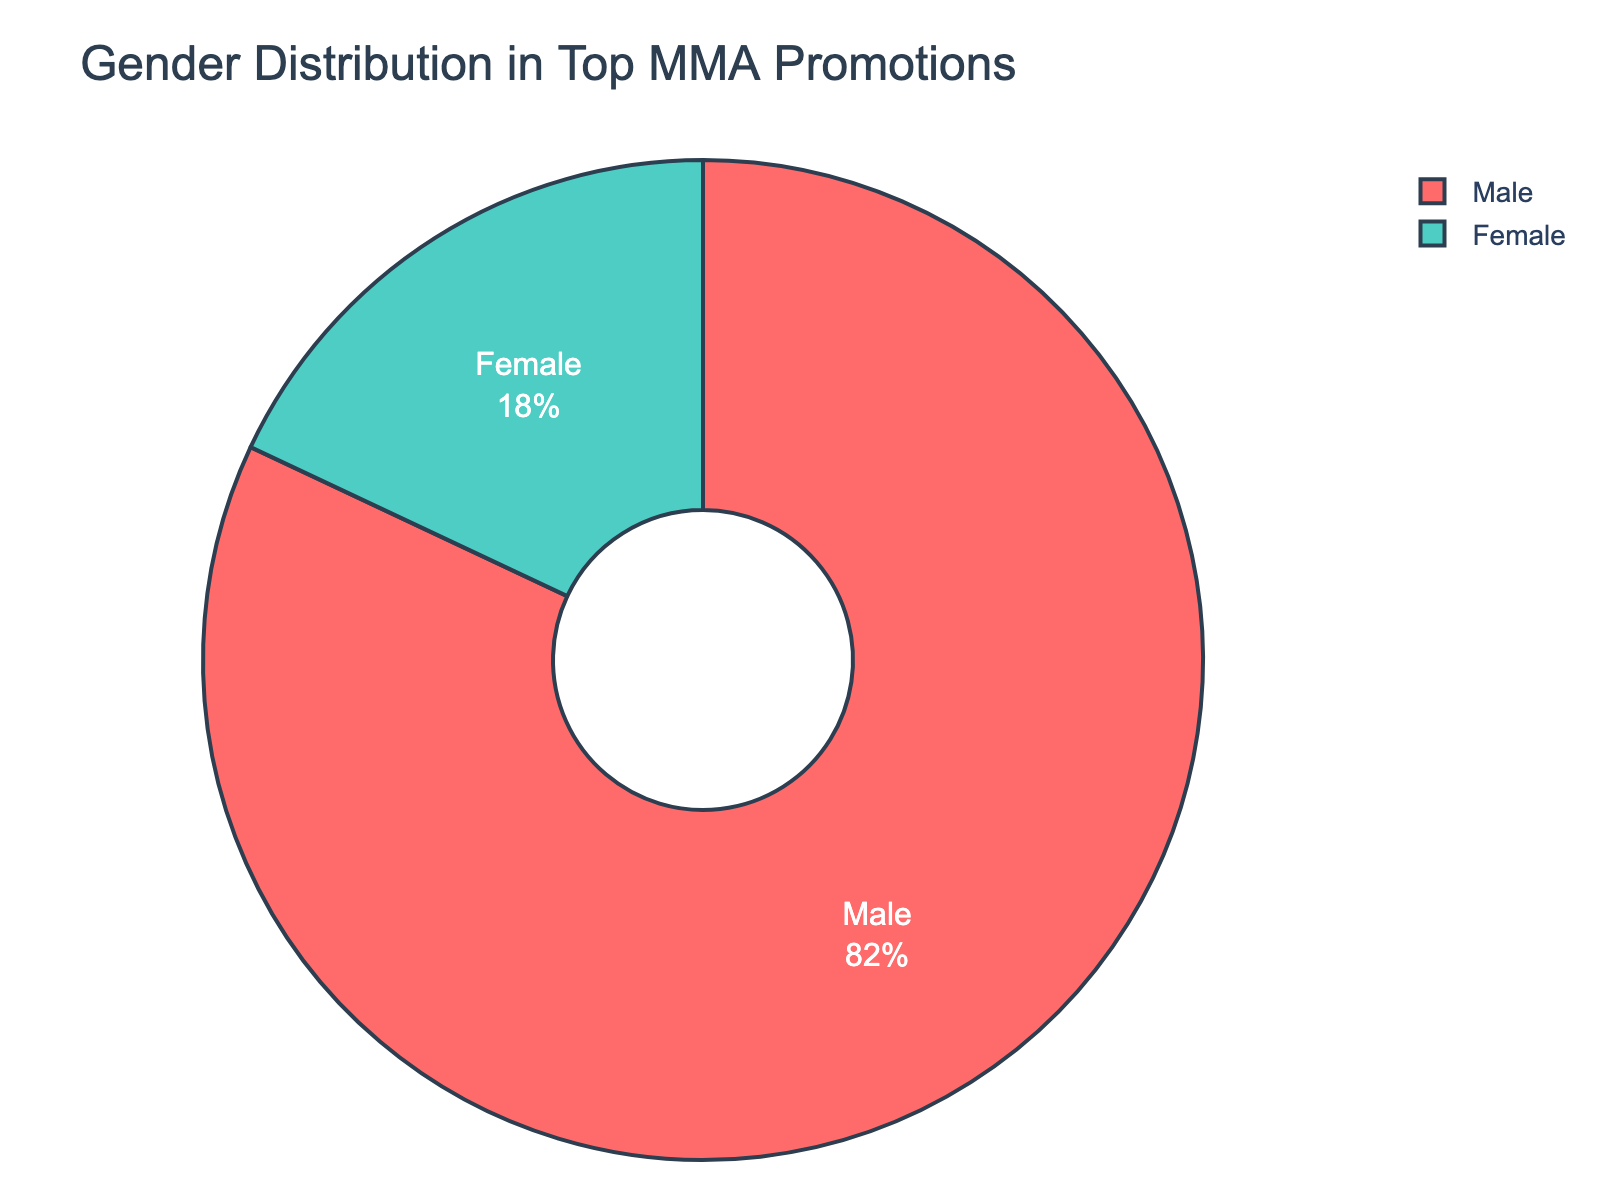What percentage of MMA fighters in top promotions are female? According to the pie chart, we can see that the segment labeled "Female" has a percentage value displayed inside it.
Answer: 18% What is the difference in percentage between male and female MMA fighters in top promotions? From the pie chart, the percentage of male fighters is 82% and female fighters is 18%. The difference can be calculated as 82% - 18%.
Answer: 64% Which gender has a higher percentage of fighters in top MMA promotions? The pie chart shows two segments labeled "Male" and "Female." The "Male" segment covers a larger portion of the chart with 82%, whereas the "Female" segment has 18%.
Answer: Male If you combine the percentage of male and female fighters, what does it total to? The pie chart represents the entire population of MMA fighters in top promotions, so the total should be 100%, as it reflects the whole distribution.
Answer: 100% What percentage of MMA fighters in top promotions are male? Referring to the pie chart, the segment labeled "Male" shows the relevant percentage inside it.
Answer: 82% How does the color differentiate between male and female fighters in the pie chart? According to the pie chart's visual attributes, the segment representing male fighters is one color (for example, red), and the segment representing female fighters is another color (for example, green).
Answer: Male fighters are red; Female fighters are green If the total number of fighters is 1,000, how many are female? The pie chart indicates that 18% of the fighters are female. To find the number of female fighters: 18% of 1000 = 0.18 * 1000 = 180.
Answer: 180 What is the ratio of male to female fighters in top MMA promotions? From the pie chart, 82% are male and 18% are female. The ratio can be calculated as 82:18. Simplifying 82:18 by dividing both by their greatest common divisor (2) gives 41:9.
Answer: 41:9 